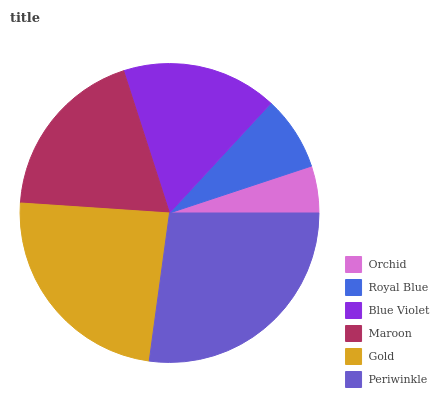Is Orchid the minimum?
Answer yes or no. Yes. Is Periwinkle the maximum?
Answer yes or no. Yes. Is Royal Blue the minimum?
Answer yes or no. No. Is Royal Blue the maximum?
Answer yes or no. No. Is Royal Blue greater than Orchid?
Answer yes or no. Yes. Is Orchid less than Royal Blue?
Answer yes or no. Yes. Is Orchid greater than Royal Blue?
Answer yes or no. No. Is Royal Blue less than Orchid?
Answer yes or no. No. Is Maroon the high median?
Answer yes or no. Yes. Is Blue Violet the low median?
Answer yes or no. Yes. Is Gold the high median?
Answer yes or no. No. Is Gold the low median?
Answer yes or no. No. 